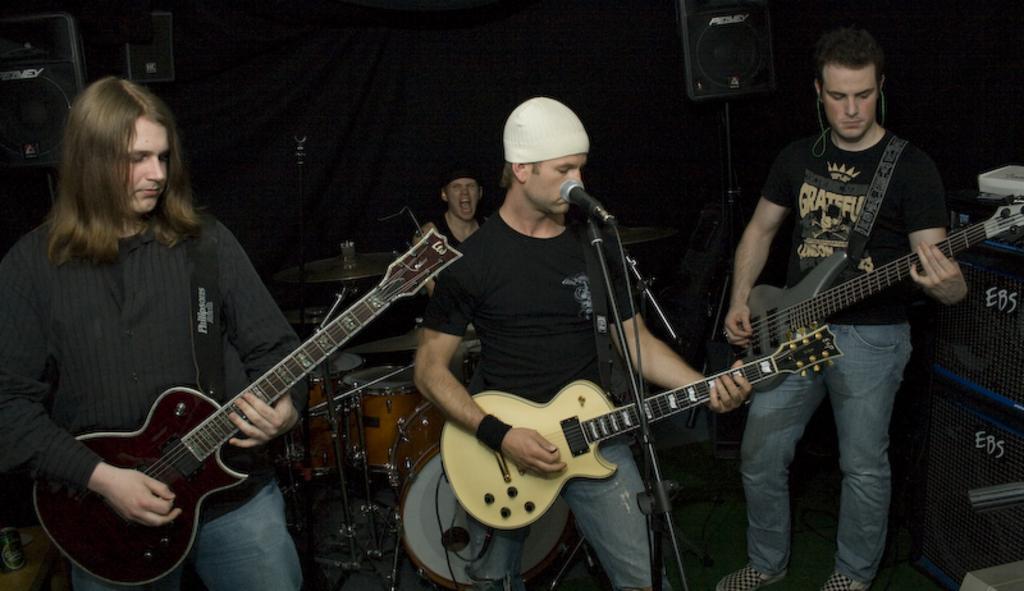Could you give a brief overview of what you see in this image? Here we can see a group of people are standing on the stage and playing the guitar, and in front here is the microphone, and at back here are a person is sitting and playing the musical drums. 